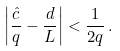Convert formula to latex. <formula><loc_0><loc_0><loc_500><loc_500>\left | \frac { \hat { c } } { q } - \frac { d } { L } \right | < \frac { 1 } { 2 q } \, .</formula> 